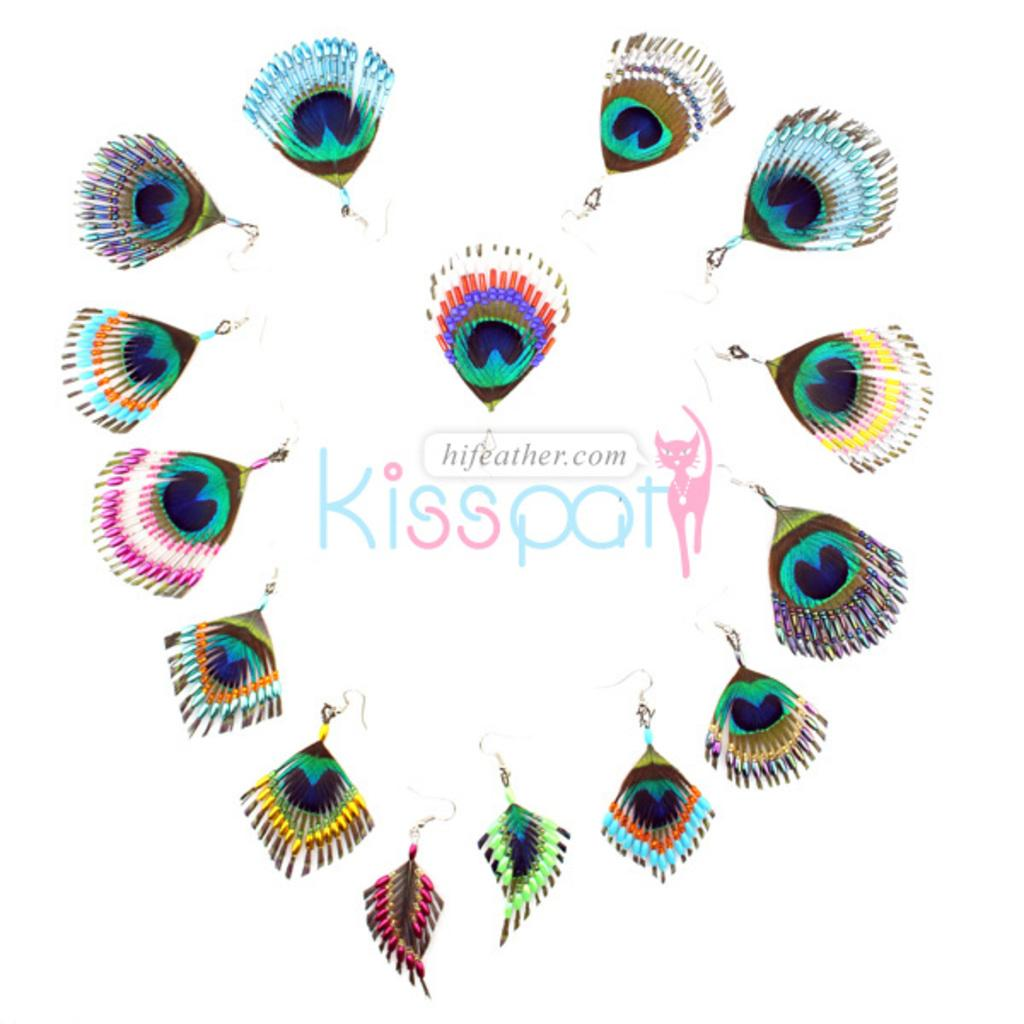What type of accessory is present in the image? There are earrings in the image. What else can be found in the image besides the earrings? There is information and an animal figure in the image. What type of throat condition can be seen in the image? There is no throat condition present in the image; it only features earrings, information, and an animal figure. 